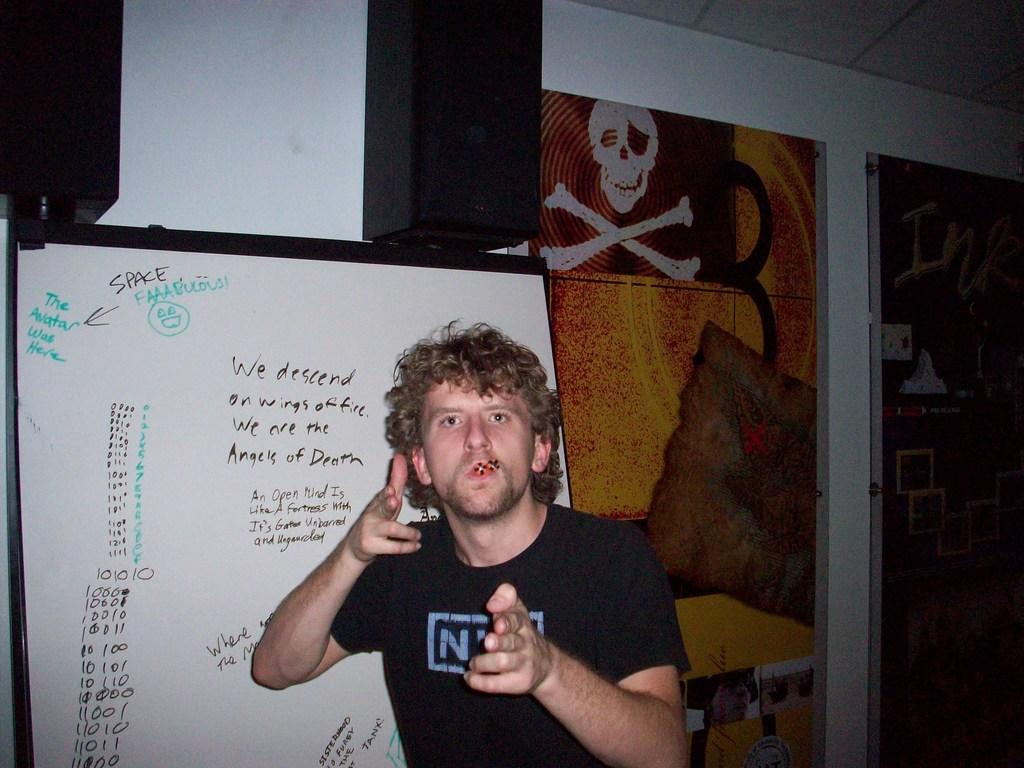Who is present in the image? There is a man in the image. What is the man wearing? The man is wearing a black T-shirt. What can be seen behind the man? There is a board behind the man. What is visible in the background of the image? There is a wall in the background of the image. What decorations are on the wall? There are banners on the wall. What type of mask is the man wearing in the image? The man is not wearing a mask in the image. What is the man thinking about in the image? The image does not show the man's thoughts or emotions. 